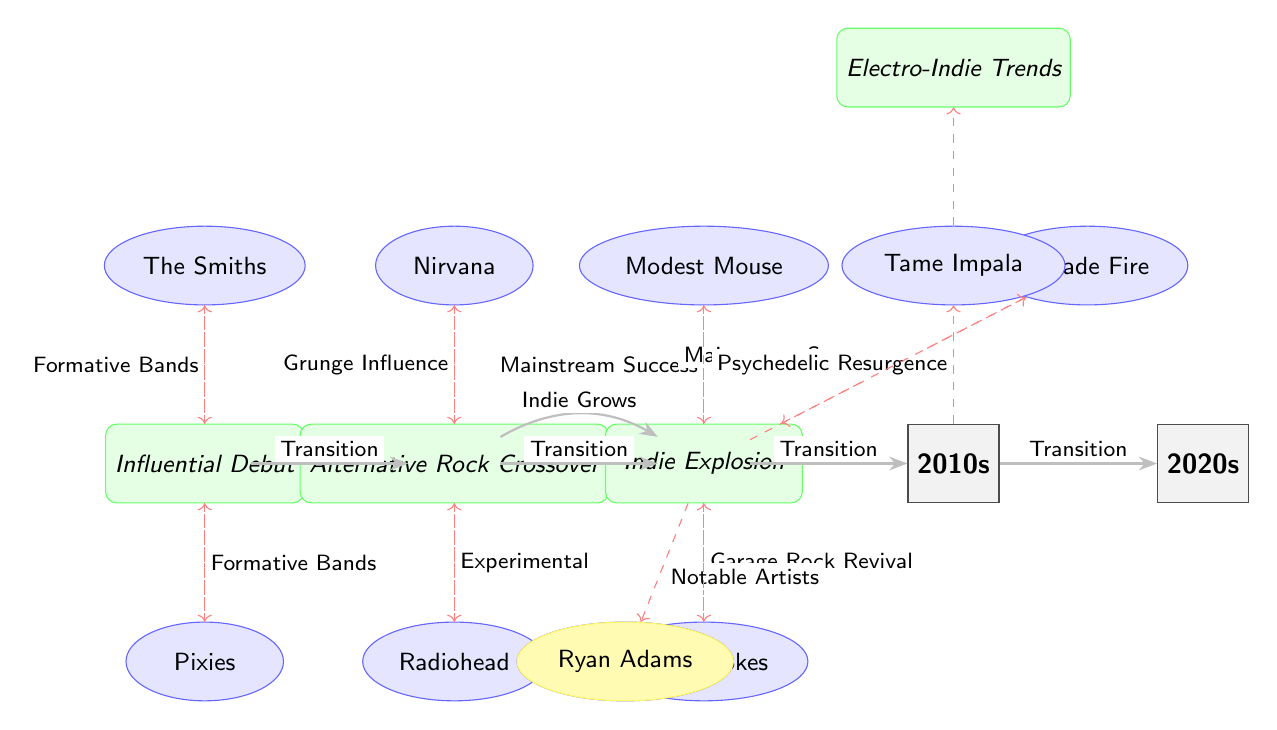What bands are represented in the 1980s? The diagram shows two bands positioned above and below the 1980s node: The Smiths and Pixies. These are the only bands listed for this decade.
Answer: The Smiths, Pixies How many decades are represented in the diagram? The diagram explicitly showcases five nodes labeled with decades, ranging from the 1980s to the 2020s.
Answer: Five What significant trend is associated with the 2000s decade? There are three trends connected to the 2000s: "Mainstream Success," "Garage Rock Revival," and "Notable Artists." The diagram specifies these connections with arrows labeled with these trends.
Answer: Indie Explosion Which band from the 1990s influenced Radiohead? The diagram shows "Radiohead" connected to a trend labeled "Experimental," while "Nirvana" is also connected to the 1990s node. Thus, "Nirvana" acts as an influential band leading to Radiohead's development.
Answer: Nirvana What is the transition labeled between the 1990s and 2000s? The diagram indicates a labeled transition between the nodes for the 1990s and 2000s, which states "Indie Grows." This captures the evolution of indie rock from one decade to the next.
Answer: Indie Grows Which band had a notable connection to the "Psychedelic Resurgence" trend? This trend is connected to Tame Impala, as depicted in the diagram. The arrow leading to this trend is drawn from the Tame Impala node.
Answer: Tame Impala What color highlights Ryan Adams in the diagram? Ryan Adams is highlighted with a light yellow background, as indicated on the node for this band in the diagram.
Answer: Yellow What type of influence is represented by the dashed line from The Smiths? The dashed line from The Smiths to "Influential Debut" indicates that the influence from this band is categorized as an "influence," characterized by its dashed appearance in the diagram.
Answer: Influence 